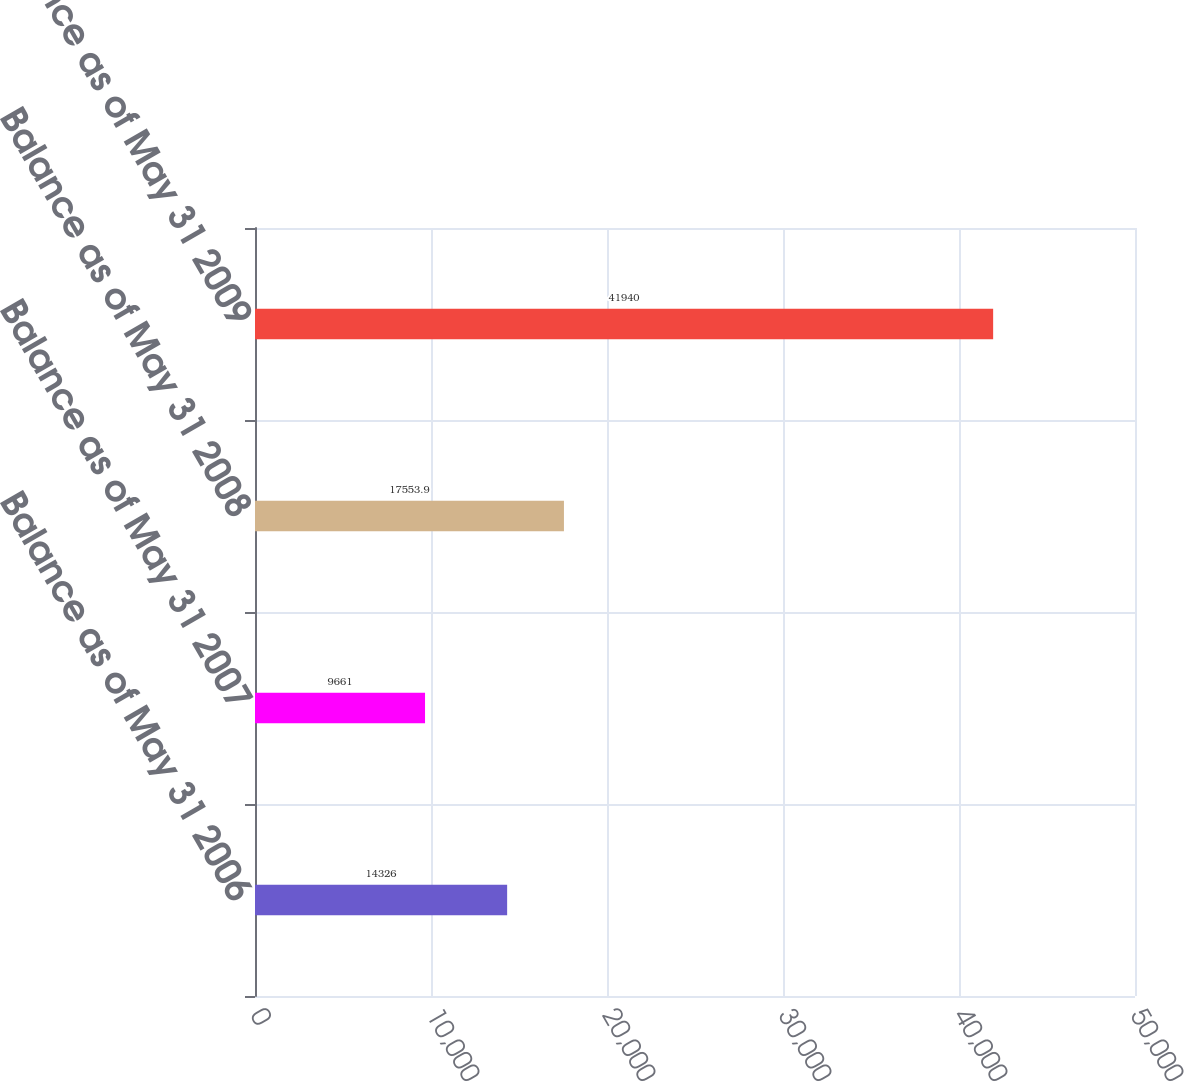Convert chart to OTSL. <chart><loc_0><loc_0><loc_500><loc_500><bar_chart><fcel>Balance as of May 31 2006<fcel>Balance as of May 31 2007<fcel>Balance as of May 31 2008<fcel>Balance as of May 31 2009<nl><fcel>14326<fcel>9661<fcel>17553.9<fcel>41940<nl></chart> 